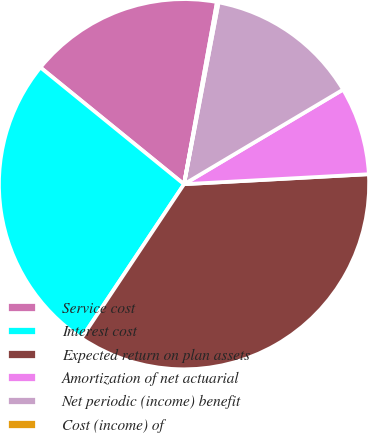<chart> <loc_0><loc_0><loc_500><loc_500><pie_chart><fcel>Service cost<fcel>Interest cost<fcel>Expected return on plan assets<fcel>Amortization of net actuarial<fcel>Net periodic (income) benefit<fcel>Cost (income) of<nl><fcel>16.98%<fcel>26.51%<fcel>35.21%<fcel>7.68%<fcel>13.47%<fcel>0.14%<nl></chart> 